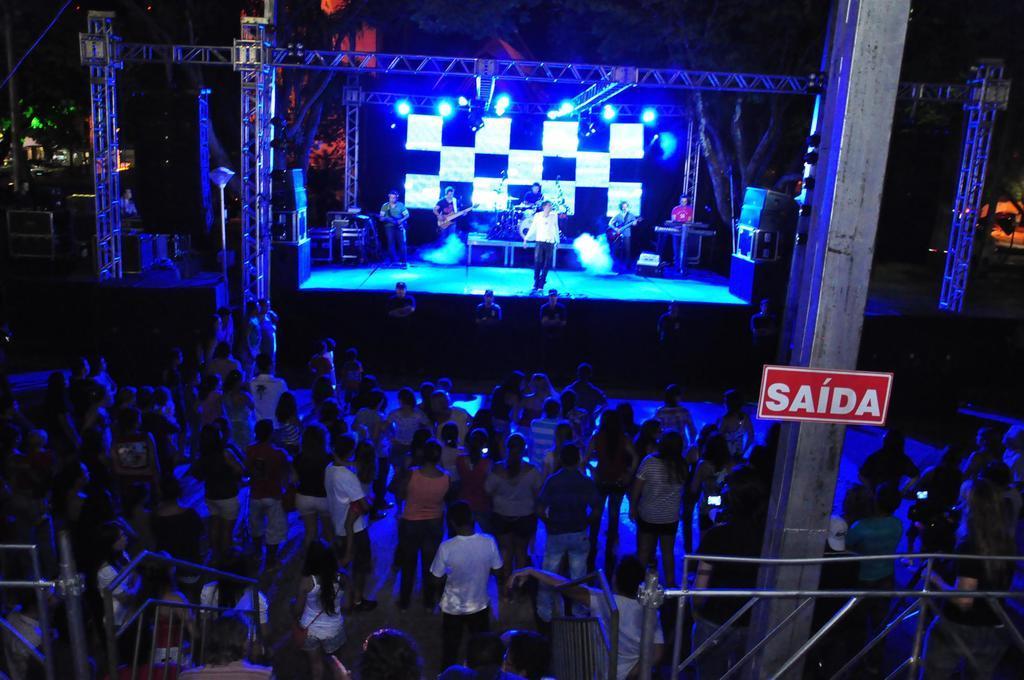In one or two sentences, can you explain what this image depicts? This picture describes about group of people, and we can see few musicians on the stage, few people are playing musical instruments, behind to them we can find metal rods and lights. 